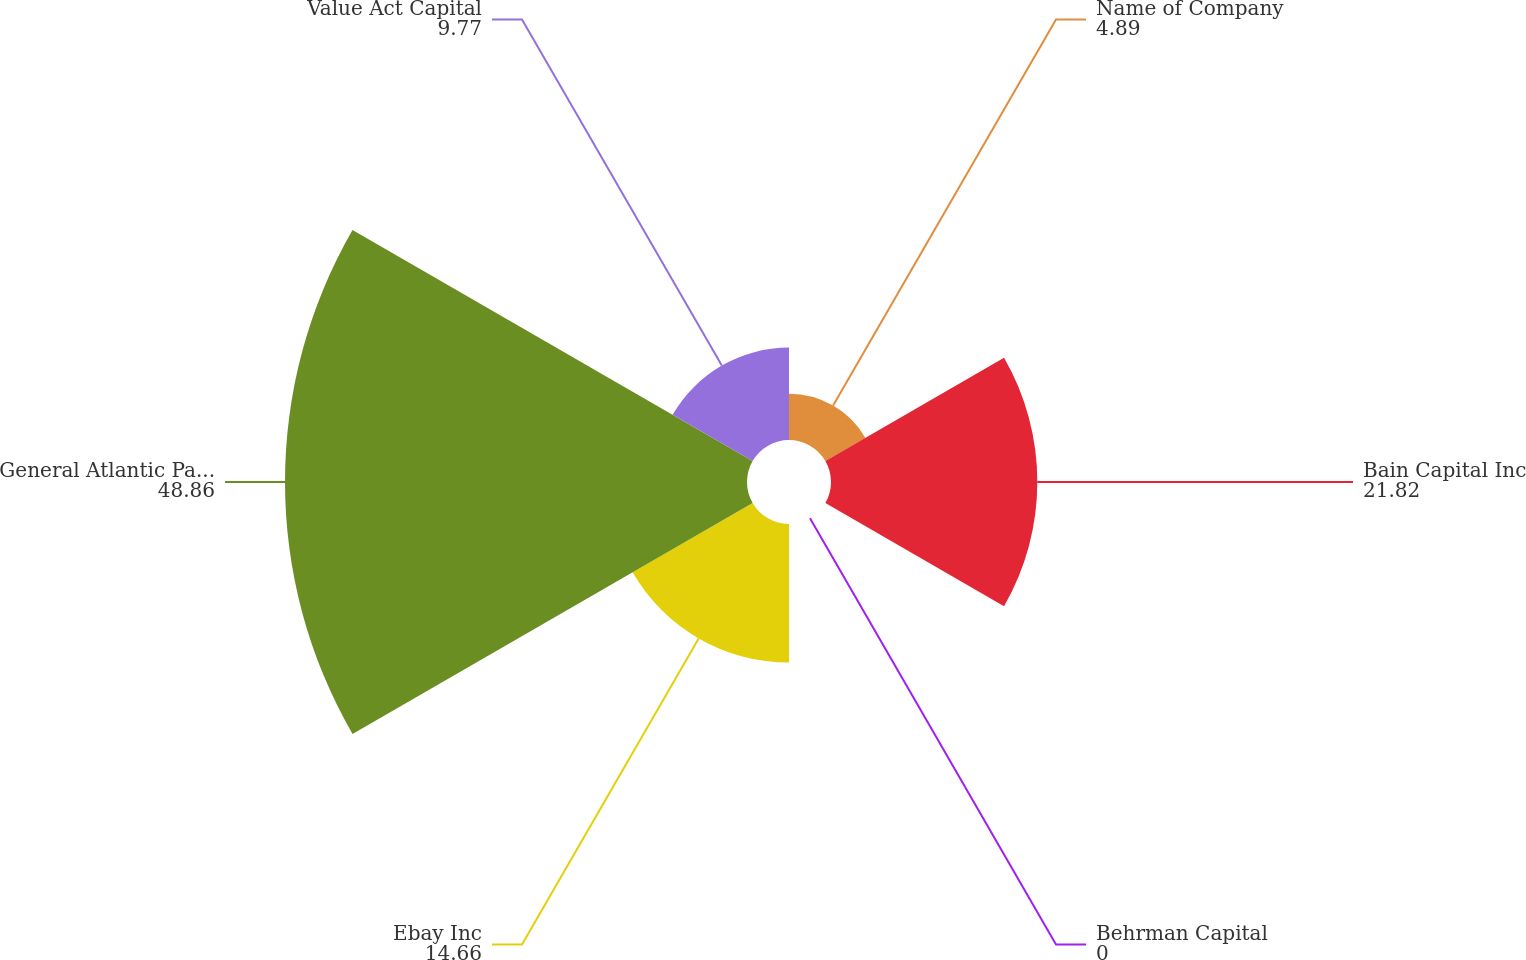Convert chart to OTSL. <chart><loc_0><loc_0><loc_500><loc_500><pie_chart><fcel>Name of Company<fcel>Bain Capital Inc<fcel>Behrman Capital<fcel>Ebay Inc<fcel>General Atlantic Partners LP<fcel>Value Act Capital<nl><fcel>4.89%<fcel>21.82%<fcel>0.0%<fcel>14.66%<fcel>48.86%<fcel>9.77%<nl></chart> 